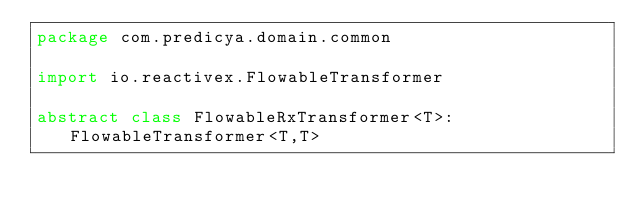Convert code to text. <code><loc_0><loc_0><loc_500><loc_500><_Kotlin_>package com.predicya.domain.common

import io.reactivex.FlowableTransformer

abstract class FlowableRxTransformer<T>: FlowableTransformer<T,T></code> 